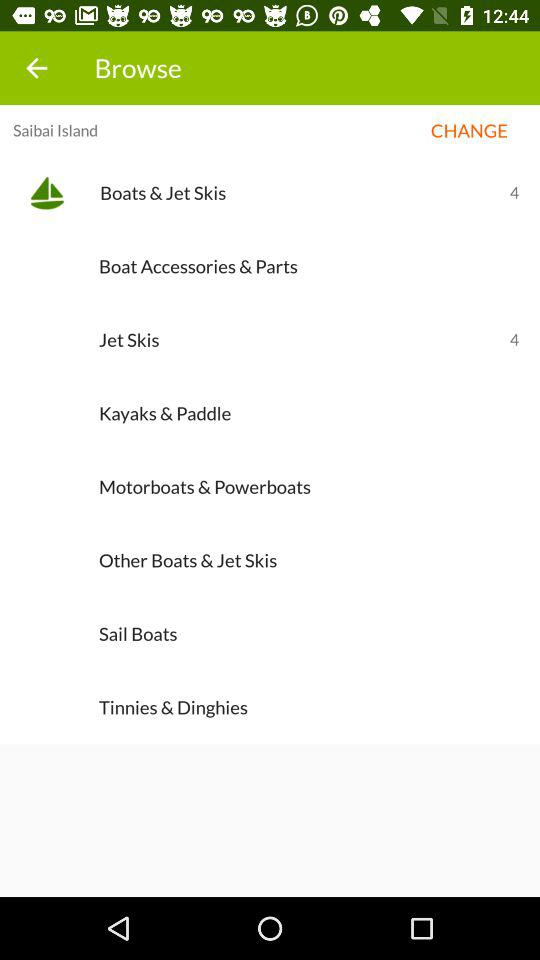What's the count for boats & jet skis? The count for boats & jet skis is 4. 